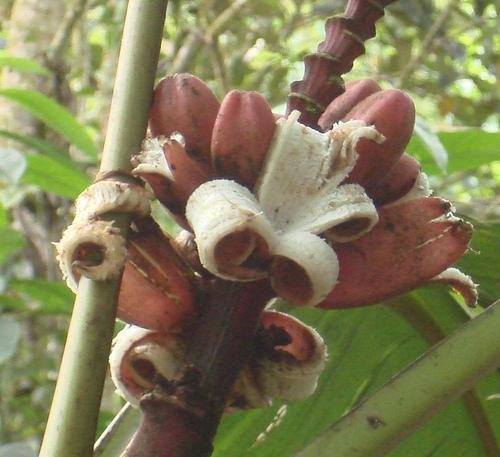How many flowers are in the photo?
Give a very brief answer. 1. 